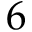<formula> <loc_0><loc_0><loc_500><loc_500>6</formula> 